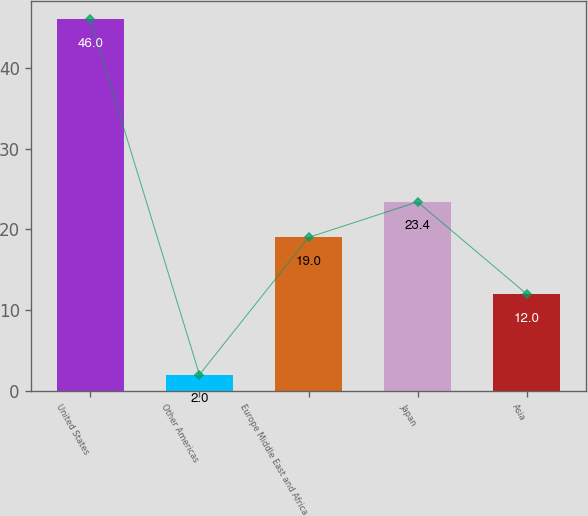<chart> <loc_0><loc_0><loc_500><loc_500><bar_chart><fcel>United States<fcel>Other Americas<fcel>Europe Middle East and Africa<fcel>Japan<fcel>Asia<nl><fcel>46<fcel>2<fcel>19<fcel>23.4<fcel>12<nl></chart> 